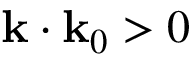Convert formula to latex. <formula><loc_0><loc_0><loc_500><loc_500>k \cdot k _ { 0 } > 0</formula> 